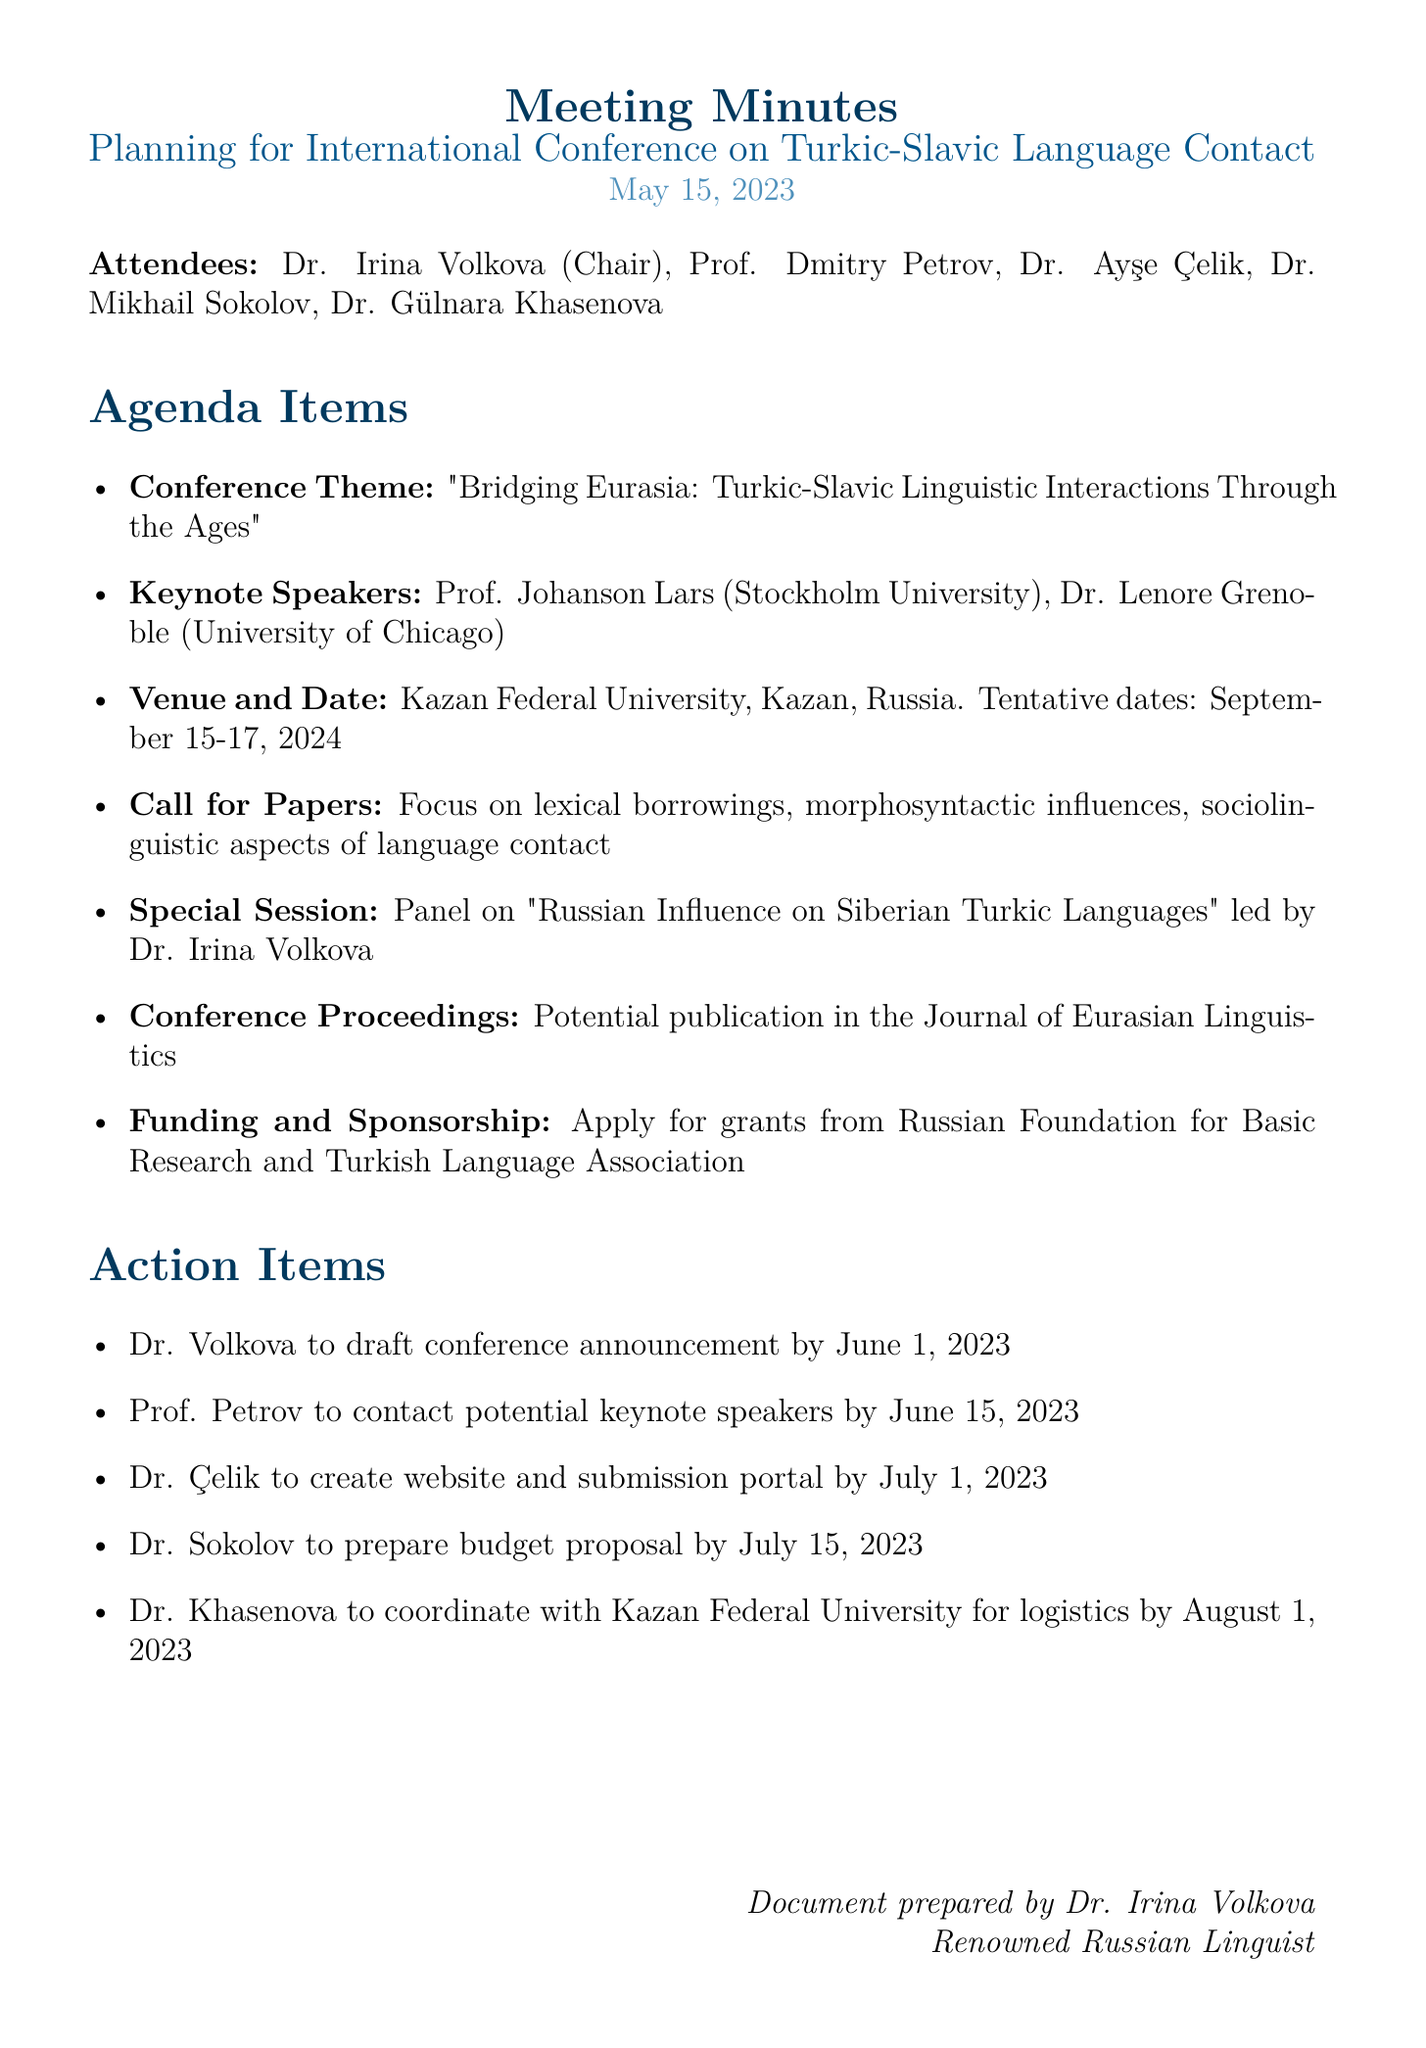What is the date of the meeting? The date of the meeting is stated at the beginning of the document.
Answer: May 15, 2023 Who is the chair of the meeting? The document lists Dr. Irina Volkova as the chair among the attendees.
Answer: Dr. Irina Volkova What is the proposed conference theme? The theme is outlined under the agenda items section.
Answer: Bridging Eurasia: Turkic-Slavic Linguistic Interactions Through the Ages Which university will host the conference? The location of the conference is mentioned under the venue and date agenda item.
Answer: Kazan Federal University What is the tentative date range for the conference? The tentative dates are specified in the venue and date section.
Answer: September 15-17, 2024 What panel is proposed for the special session? The special session topic is included in the agenda items and provides specific details.
Answer: Russian Influence on Siberian Turkic Languages What is the focus of the call for papers? The focus areas are listed in the call for papers agenda item.
Answer: Lexical borrowings, morphosyntactic influences, sociolinguistic aspects of language contact Who will prepare the budget proposal? The action items specify who is responsible for each task.
Answer: Dr. Sokolov What is one of the funding sources mentioned? The funding and sponsorship section references potential grants.
Answer: Russian Foundation for Basic Research 